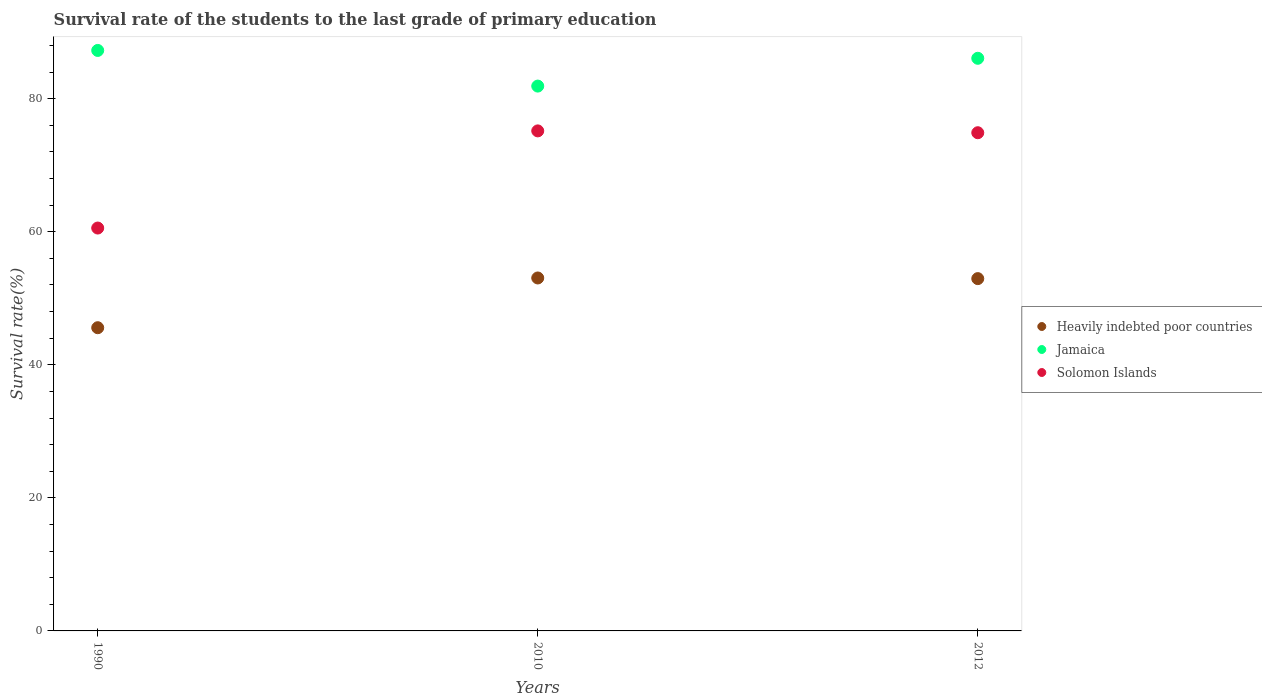How many different coloured dotlines are there?
Keep it short and to the point. 3. Is the number of dotlines equal to the number of legend labels?
Your answer should be compact. Yes. What is the survival rate of the students in Heavily indebted poor countries in 2010?
Your response must be concise. 53.06. Across all years, what is the maximum survival rate of the students in Heavily indebted poor countries?
Make the answer very short. 53.06. Across all years, what is the minimum survival rate of the students in Heavily indebted poor countries?
Provide a short and direct response. 45.58. In which year was the survival rate of the students in Solomon Islands maximum?
Your response must be concise. 2010. What is the total survival rate of the students in Jamaica in the graph?
Make the answer very short. 255.24. What is the difference between the survival rate of the students in Jamaica in 2010 and that in 2012?
Your answer should be compact. -4.18. What is the difference between the survival rate of the students in Heavily indebted poor countries in 1990 and the survival rate of the students in Jamaica in 2012?
Ensure brevity in your answer.  -40.5. What is the average survival rate of the students in Solomon Islands per year?
Offer a very short reply. 70.21. In the year 1990, what is the difference between the survival rate of the students in Jamaica and survival rate of the students in Heavily indebted poor countries?
Your response must be concise. 41.68. What is the ratio of the survival rate of the students in Heavily indebted poor countries in 1990 to that in 2010?
Your response must be concise. 0.86. Is the difference between the survival rate of the students in Jamaica in 1990 and 2010 greater than the difference between the survival rate of the students in Heavily indebted poor countries in 1990 and 2010?
Make the answer very short. Yes. What is the difference between the highest and the second highest survival rate of the students in Solomon Islands?
Ensure brevity in your answer.  0.28. What is the difference between the highest and the lowest survival rate of the students in Jamaica?
Keep it short and to the point. 5.36. Is the survival rate of the students in Solomon Islands strictly less than the survival rate of the students in Heavily indebted poor countries over the years?
Keep it short and to the point. No. How many years are there in the graph?
Offer a terse response. 3. What is the difference between two consecutive major ticks on the Y-axis?
Offer a terse response. 20. Are the values on the major ticks of Y-axis written in scientific E-notation?
Offer a very short reply. No. Does the graph contain any zero values?
Offer a very short reply. No. What is the title of the graph?
Keep it short and to the point. Survival rate of the students to the last grade of primary education. What is the label or title of the Y-axis?
Your answer should be compact. Survival rate(%). What is the Survival rate(%) of Heavily indebted poor countries in 1990?
Offer a very short reply. 45.58. What is the Survival rate(%) in Jamaica in 1990?
Keep it short and to the point. 87.26. What is the Survival rate(%) of Solomon Islands in 1990?
Offer a terse response. 60.56. What is the Survival rate(%) of Heavily indebted poor countries in 2010?
Offer a terse response. 53.06. What is the Survival rate(%) of Jamaica in 2010?
Ensure brevity in your answer.  81.9. What is the Survival rate(%) in Solomon Islands in 2010?
Ensure brevity in your answer.  75.17. What is the Survival rate(%) in Heavily indebted poor countries in 2012?
Offer a terse response. 52.96. What is the Survival rate(%) in Jamaica in 2012?
Make the answer very short. 86.08. What is the Survival rate(%) of Solomon Islands in 2012?
Give a very brief answer. 74.89. Across all years, what is the maximum Survival rate(%) of Heavily indebted poor countries?
Provide a succinct answer. 53.06. Across all years, what is the maximum Survival rate(%) in Jamaica?
Your response must be concise. 87.26. Across all years, what is the maximum Survival rate(%) in Solomon Islands?
Provide a succinct answer. 75.17. Across all years, what is the minimum Survival rate(%) in Heavily indebted poor countries?
Give a very brief answer. 45.58. Across all years, what is the minimum Survival rate(%) of Jamaica?
Your answer should be very brief. 81.9. Across all years, what is the minimum Survival rate(%) of Solomon Islands?
Your answer should be compact. 60.56. What is the total Survival rate(%) in Heavily indebted poor countries in the graph?
Keep it short and to the point. 151.59. What is the total Survival rate(%) in Jamaica in the graph?
Your response must be concise. 255.24. What is the total Survival rate(%) of Solomon Islands in the graph?
Make the answer very short. 210.62. What is the difference between the Survival rate(%) of Heavily indebted poor countries in 1990 and that in 2010?
Give a very brief answer. -7.48. What is the difference between the Survival rate(%) of Jamaica in 1990 and that in 2010?
Provide a succinct answer. 5.36. What is the difference between the Survival rate(%) of Solomon Islands in 1990 and that in 2010?
Provide a short and direct response. -14.6. What is the difference between the Survival rate(%) of Heavily indebted poor countries in 1990 and that in 2012?
Keep it short and to the point. -7.38. What is the difference between the Survival rate(%) in Jamaica in 1990 and that in 2012?
Provide a short and direct response. 1.18. What is the difference between the Survival rate(%) in Solomon Islands in 1990 and that in 2012?
Keep it short and to the point. -14.33. What is the difference between the Survival rate(%) in Heavily indebted poor countries in 2010 and that in 2012?
Offer a very short reply. 0.1. What is the difference between the Survival rate(%) in Jamaica in 2010 and that in 2012?
Give a very brief answer. -4.18. What is the difference between the Survival rate(%) in Solomon Islands in 2010 and that in 2012?
Your response must be concise. 0.28. What is the difference between the Survival rate(%) of Heavily indebted poor countries in 1990 and the Survival rate(%) of Jamaica in 2010?
Your answer should be very brief. -36.32. What is the difference between the Survival rate(%) in Heavily indebted poor countries in 1990 and the Survival rate(%) in Solomon Islands in 2010?
Give a very brief answer. -29.59. What is the difference between the Survival rate(%) of Jamaica in 1990 and the Survival rate(%) of Solomon Islands in 2010?
Make the answer very short. 12.09. What is the difference between the Survival rate(%) in Heavily indebted poor countries in 1990 and the Survival rate(%) in Jamaica in 2012?
Keep it short and to the point. -40.5. What is the difference between the Survival rate(%) in Heavily indebted poor countries in 1990 and the Survival rate(%) in Solomon Islands in 2012?
Provide a succinct answer. -29.31. What is the difference between the Survival rate(%) of Jamaica in 1990 and the Survival rate(%) of Solomon Islands in 2012?
Your answer should be very brief. 12.37. What is the difference between the Survival rate(%) of Heavily indebted poor countries in 2010 and the Survival rate(%) of Jamaica in 2012?
Offer a very short reply. -33.02. What is the difference between the Survival rate(%) of Heavily indebted poor countries in 2010 and the Survival rate(%) of Solomon Islands in 2012?
Offer a very short reply. -21.83. What is the difference between the Survival rate(%) in Jamaica in 2010 and the Survival rate(%) in Solomon Islands in 2012?
Your response must be concise. 7.01. What is the average Survival rate(%) in Heavily indebted poor countries per year?
Ensure brevity in your answer.  50.53. What is the average Survival rate(%) in Jamaica per year?
Offer a terse response. 85.08. What is the average Survival rate(%) of Solomon Islands per year?
Your response must be concise. 70.21. In the year 1990, what is the difference between the Survival rate(%) of Heavily indebted poor countries and Survival rate(%) of Jamaica?
Provide a succinct answer. -41.68. In the year 1990, what is the difference between the Survival rate(%) of Heavily indebted poor countries and Survival rate(%) of Solomon Islands?
Your answer should be compact. -14.98. In the year 1990, what is the difference between the Survival rate(%) of Jamaica and Survival rate(%) of Solomon Islands?
Provide a short and direct response. 26.7. In the year 2010, what is the difference between the Survival rate(%) in Heavily indebted poor countries and Survival rate(%) in Jamaica?
Your answer should be compact. -28.84. In the year 2010, what is the difference between the Survival rate(%) in Heavily indebted poor countries and Survival rate(%) in Solomon Islands?
Provide a short and direct response. -22.11. In the year 2010, what is the difference between the Survival rate(%) in Jamaica and Survival rate(%) in Solomon Islands?
Provide a succinct answer. 6.73. In the year 2012, what is the difference between the Survival rate(%) in Heavily indebted poor countries and Survival rate(%) in Jamaica?
Provide a short and direct response. -33.12. In the year 2012, what is the difference between the Survival rate(%) of Heavily indebted poor countries and Survival rate(%) of Solomon Islands?
Ensure brevity in your answer.  -21.93. In the year 2012, what is the difference between the Survival rate(%) of Jamaica and Survival rate(%) of Solomon Islands?
Ensure brevity in your answer.  11.19. What is the ratio of the Survival rate(%) in Heavily indebted poor countries in 1990 to that in 2010?
Offer a very short reply. 0.86. What is the ratio of the Survival rate(%) of Jamaica in 1990 to that in 2010?
Your response must be concise. 1.07. What is the ratio of the Survival rate(%) of Solomon Islands in 1990 to that in 2010?
Make the answer very short. 0.81. What is the ratio of the Survival rate(%) in Heavily indebted poor countries in 1990 to that in 2012?
Your response must be concise. 0.86. What is the ratio of the Survival rate(%) of Jamaica in 1990 to that in 2012?
Make the answer very short. 1.01. What is the ratio of the Survival rate(%) in Solomon Islands in 1990 to that in 2012?
Ensure brevity in your answer.  0.81. What is the ratio of the Survival rate(%) in Heavily indebted poor countries in 2010 to that in 2012?
Offer a terse response. 1. What is the ratio of the Survival rate(%) in Jamaica in 2010 to that in 2012?
Give a very brief answer. 0.95. What is the difference between the highest and the second highest Survival rate(%) of Heavily indebted poor countries?
Ensure brevity in your answer.  0.1. What is the difference between the highest and the second highest Survival rate(%) of Jamaica?
Offer a terse response. 1.18. What is the difference between the highest and the second highest Survival rate(%) in Solomon Islands?
Your response must be concise. 0.28. What is the difference between the highest and the lowest Survival rate(%) of Heavily indebted poor countries?
Your answer should be very brief. 7.48. What is the difference between the highest and the lowest Survival rate(%) in Jamaica?
Provide a succinct answer. 5.36. What is the difference between the highest and the lowest Survival rate(%) in Solomon Islands?
Give a very brief answer. 14.6. 